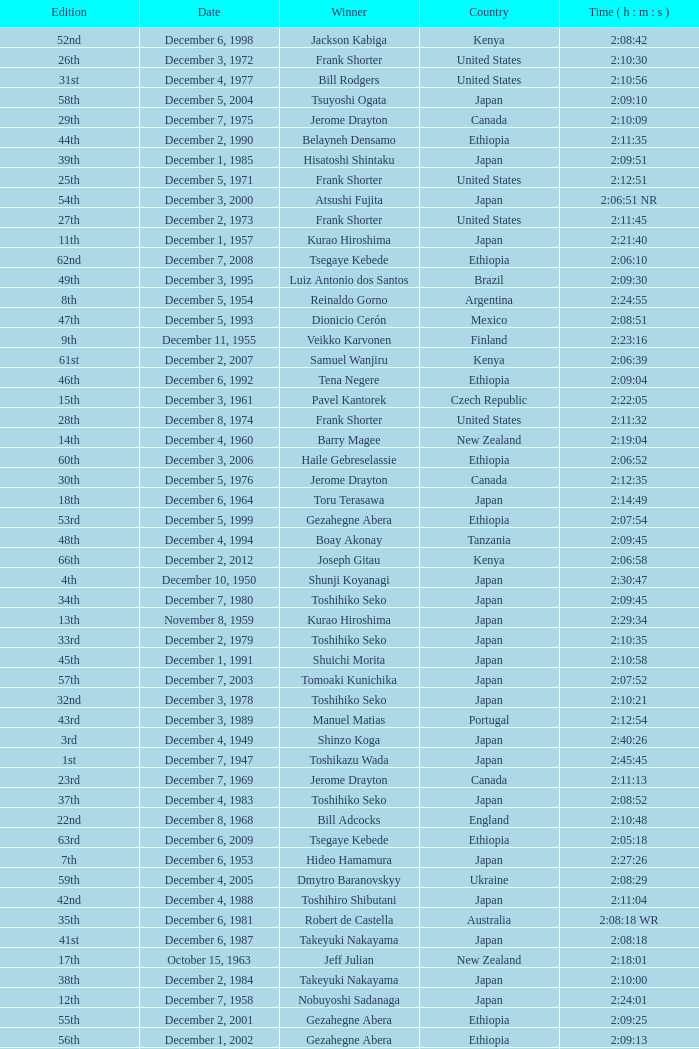What was the nationality of the winner of the 42nd Edition? Japan. 